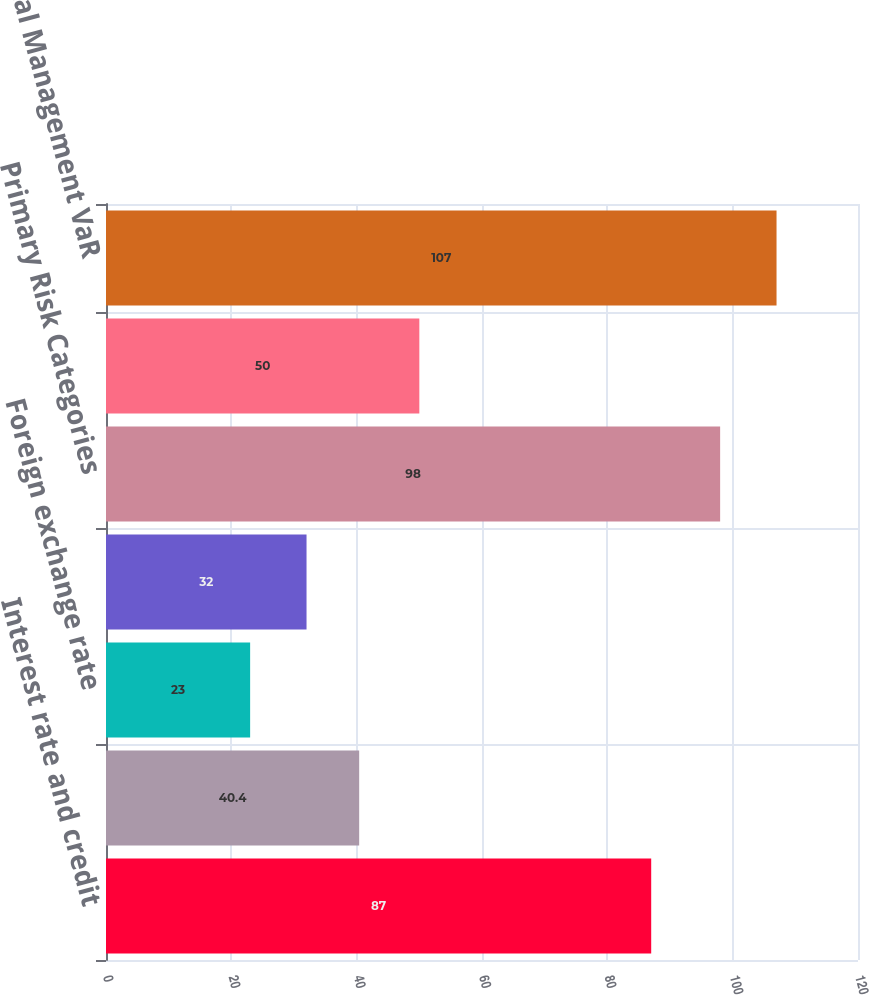<chart> <loc_0><loc_0><loc_500><loc_500><bar_chart><fcel>Interest rate and credit<fcel>Equity price<fcel>Foreign exchange rate<fcel>Commodity price<fcel>Primary Risk Categories<fcel>Credit Portfolio<fcel>Total Management VaR<nl><fcel>87<fcel>40.4<fcel>23<fcel>32<fcel>98<fcel>50<fcel>107<nl></chart> 